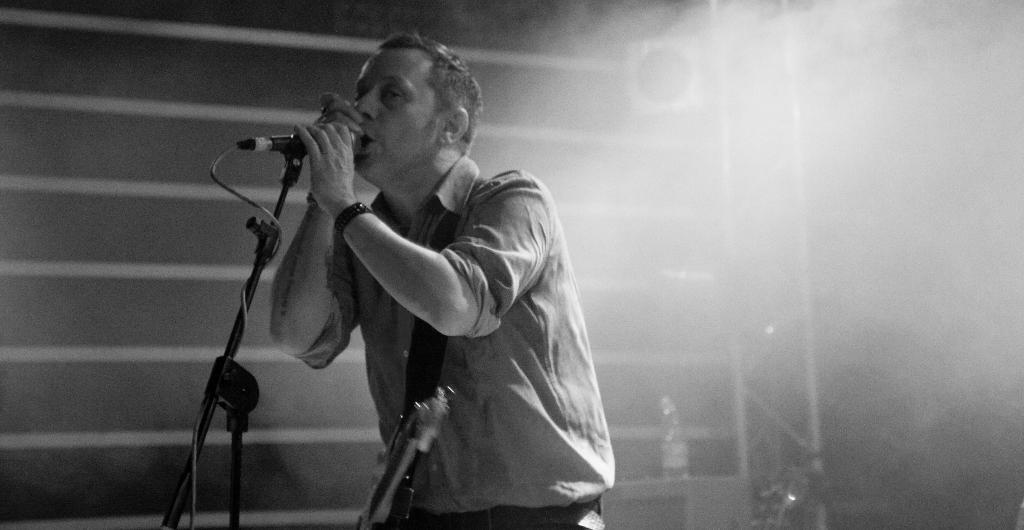What can be seen in the background of the image? There is a wall in the image. What is the person in the image doing? The person is standing and holding a microphone. Can you describe the lighting in the image? The image appears to be slightly dark. How many cards can be seen on the seashore in the image? There is no seashore or cards present in the image. 